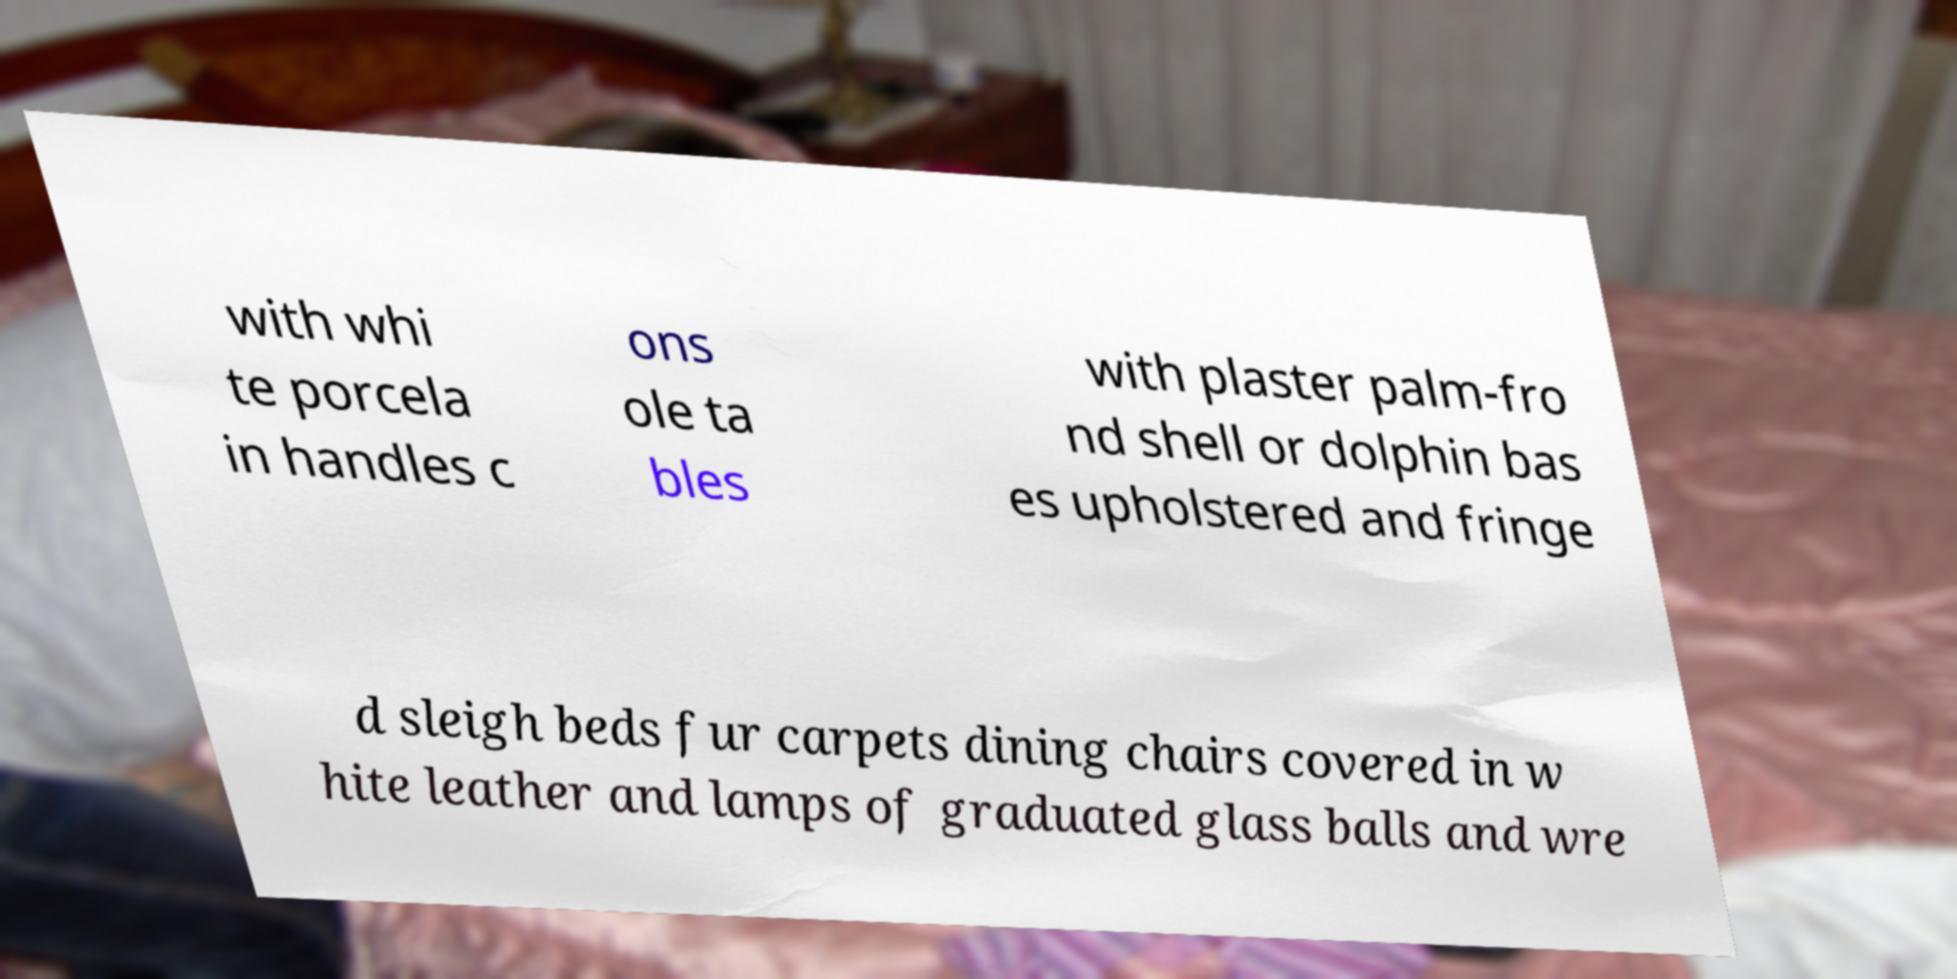Can you accurately transcribe the text from the provided image for me? with whi te porcela in handles c ons ole ta bles with plaster palm-fro nd shell or dolphin bas es upholstered and fringe d sleigh beds fur carpets dining chairs covered in w hite leather and lamps of graduated glass balls and wre 